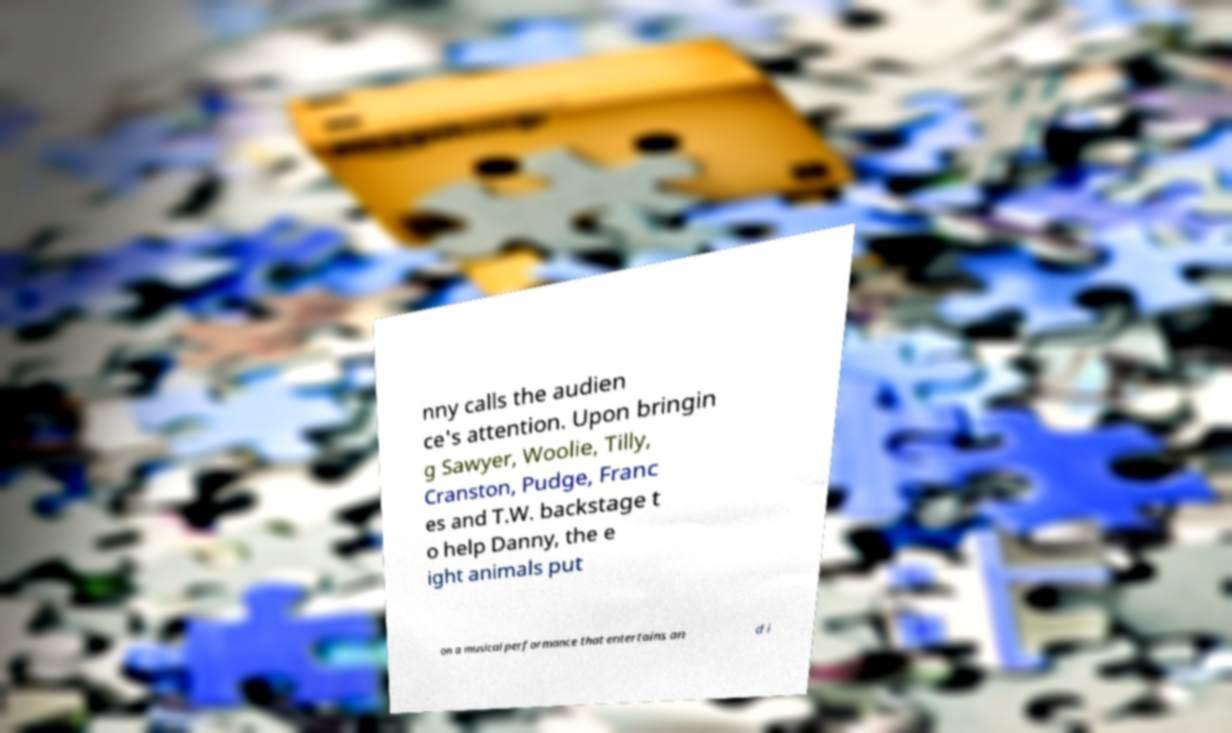Could you extract and type out the text from this image? nny calls the audien ce's attention. Upon bringin g Sawyer, Woolie, Tilly, Cranston, Pudge, Franc es and T.W. backstage t o help Danny, the e ight animals put on a musical performance that entertains an d i 